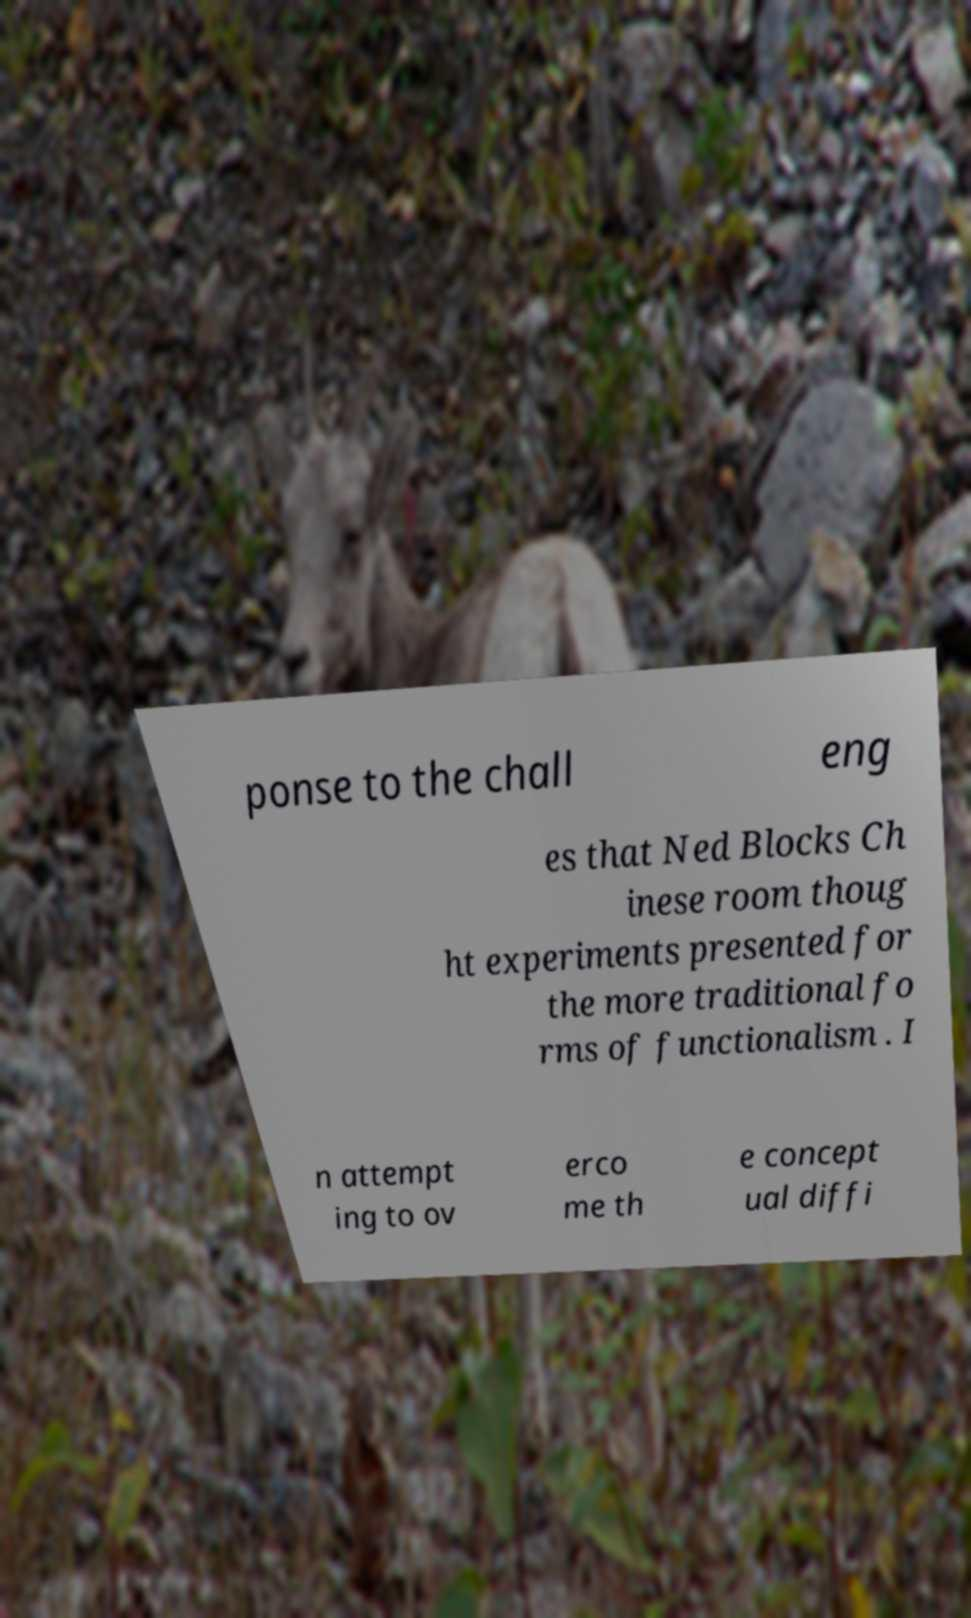For documentation purposes, I need the text within this image transcribed. Could you provide that? ponse to the chall eng es that Ned Blocks Ch inese room thoug ht experiments presented for the more traditional fo rms of functionalism . I n attempt ing to ov erco me th e concept ual diffi 